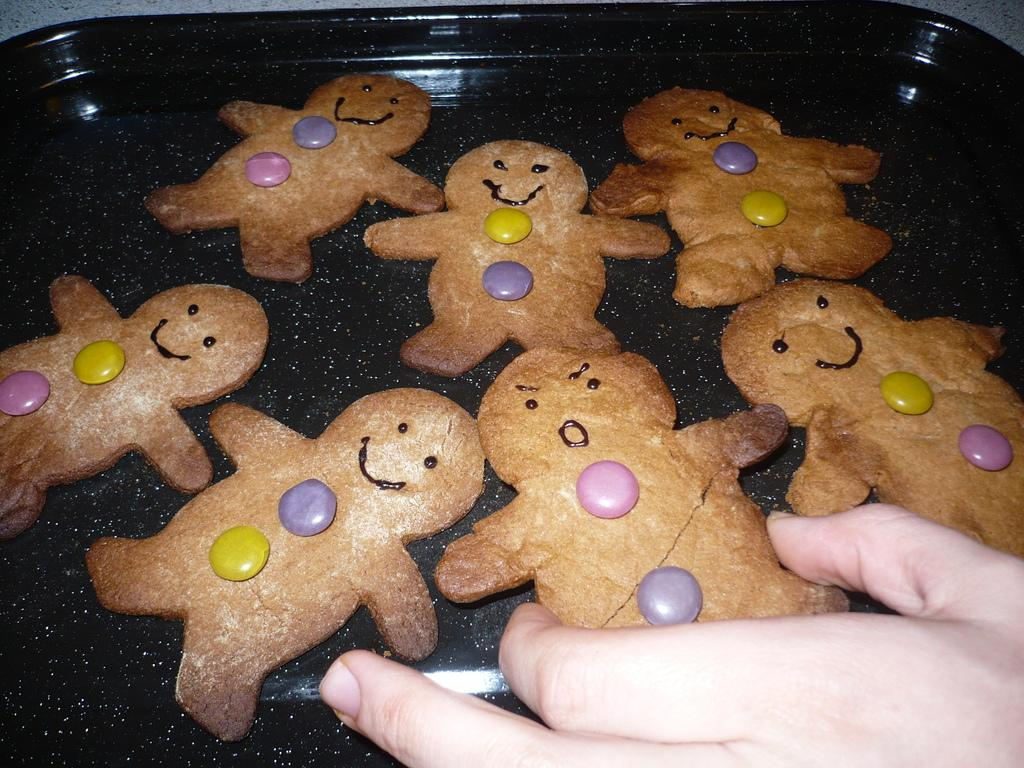What type of food can be seen in the image? There are cookies in the image. How are the cookies arranged or contained in the image? The cookies are in a tray. Can you identify any human presence in the image? Yes, there is a hand of a person visible in the image. How many dogs are present in the image? There are no dogs present in the image. What type of snakes can be seen slithering on the cookies? There are no snakes present in the image, and the cookies are in a tray, not exposed to any slithering creatures. 